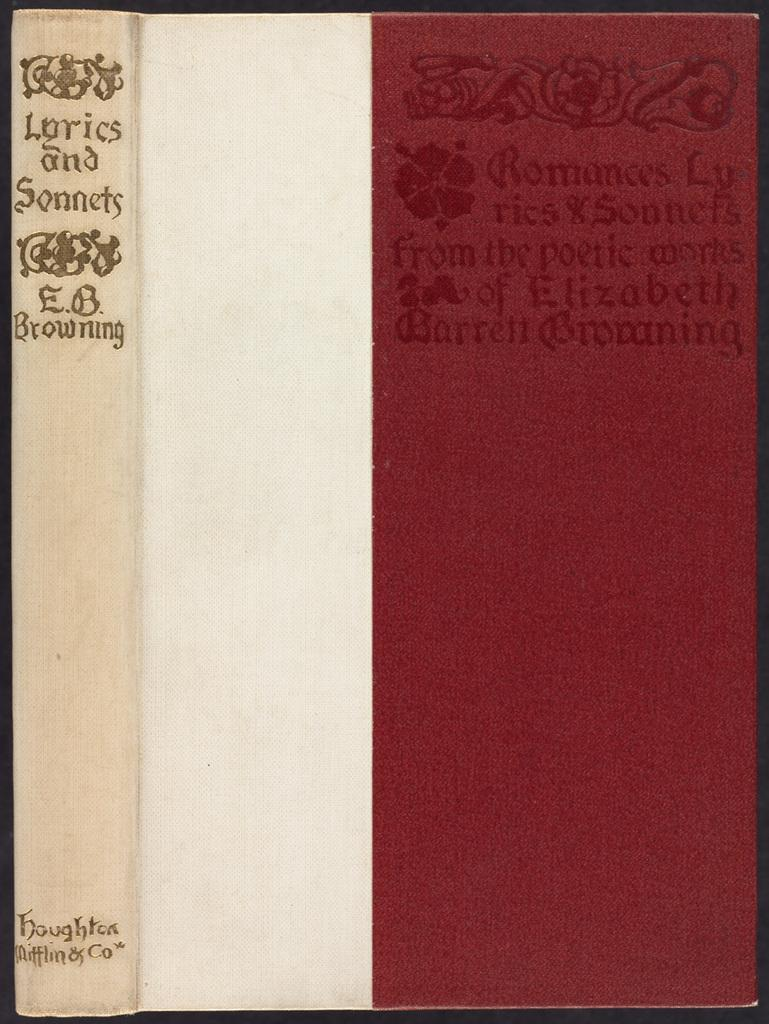<image>
Create a compact narrative representing the image presented. A White and red book is titled Lyrics and Sonnets. 